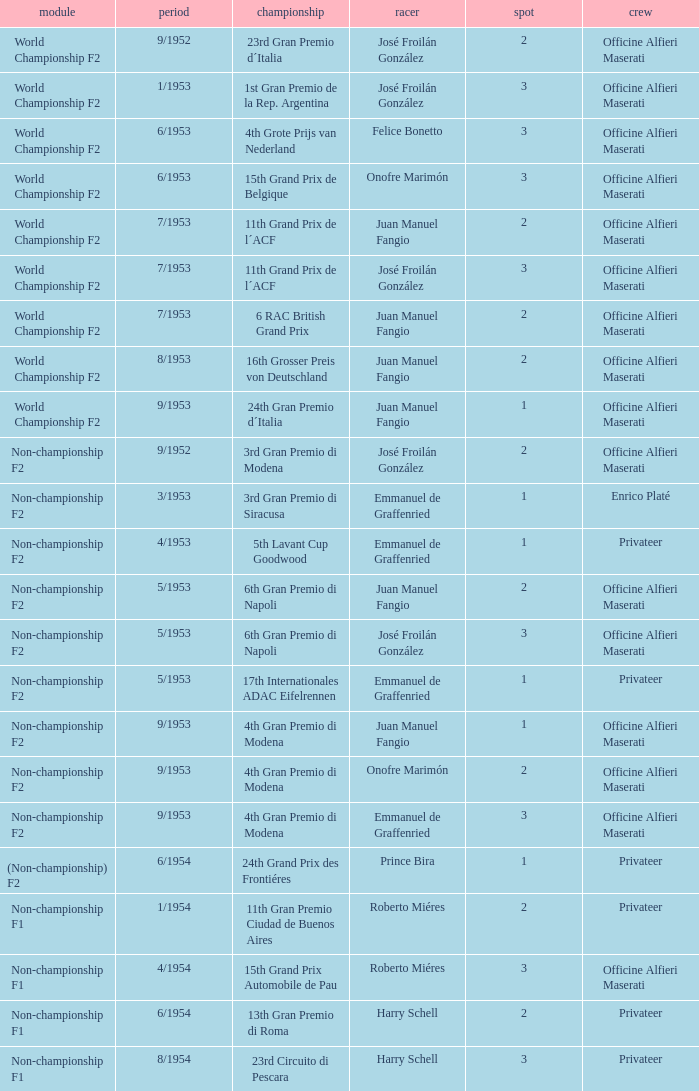What team has a drive name emmanuel de graffenried and a position larger than 1 as well as the date of 9/1953? Officine Alfieri Maserati. 